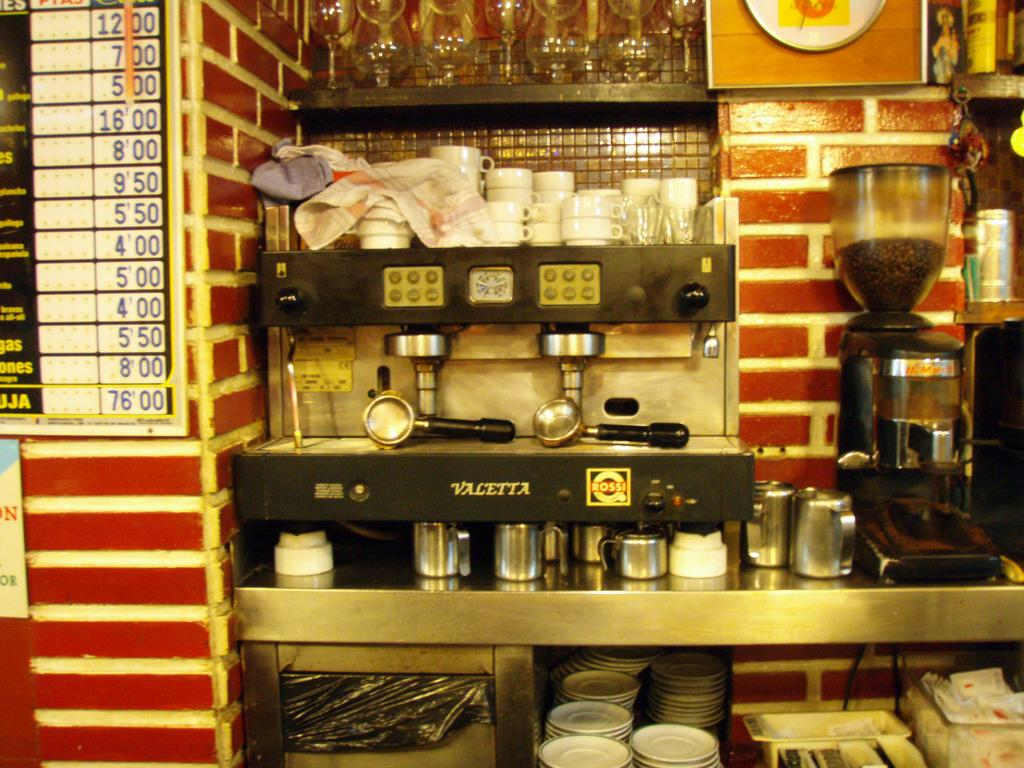<image>
Give a short and clear explanation of the subsequent image. A Valetta espresso machine  sits in front of a brick wall. 